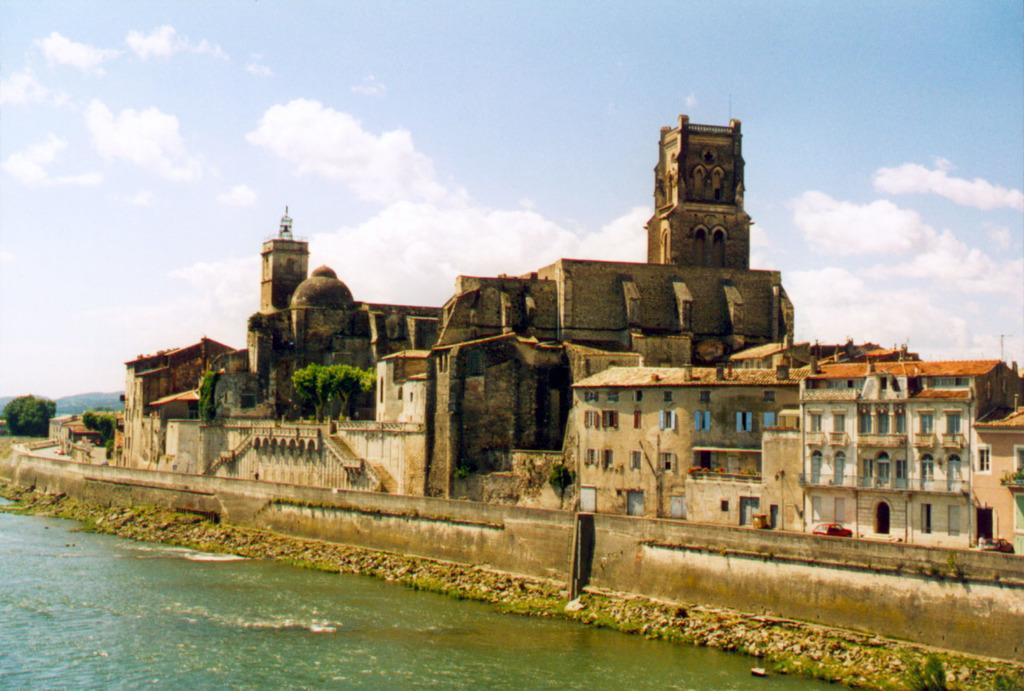In one or two sentences, can you explain what this image depicts? In this image I can see there is a lake, a fort, buildings and vehicles parked on the road, trees and the sky is clear. 